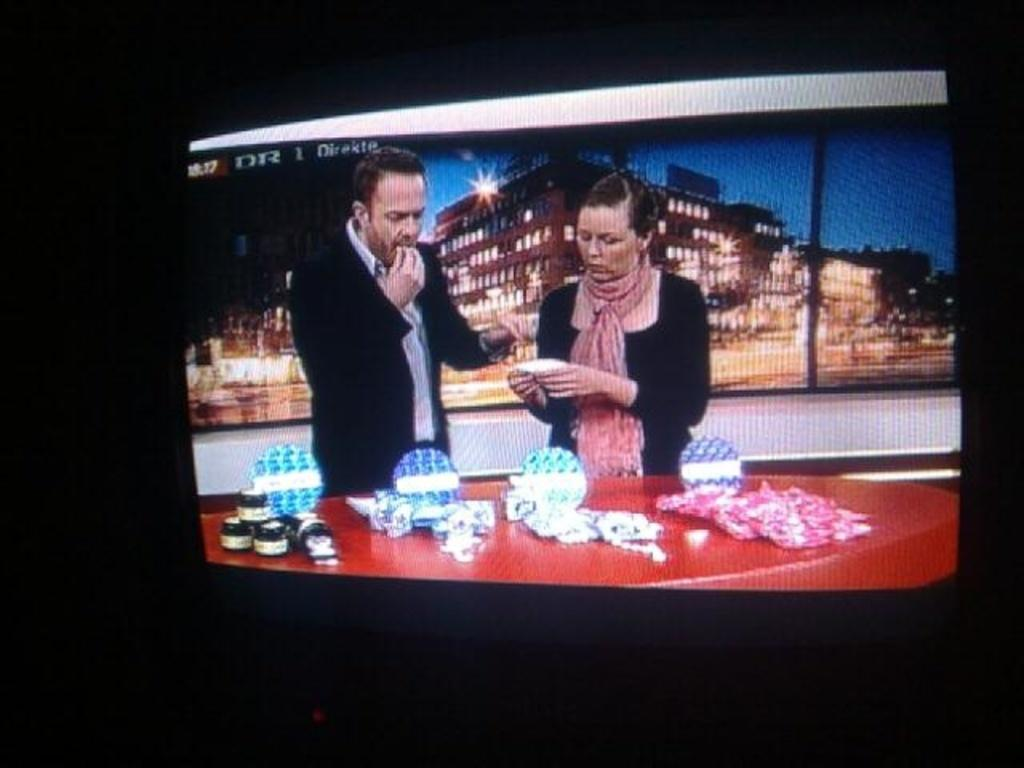<image>
Write a terse but informative summary of the picture. Two people on a talk show at taking place at 10:17 on DR. 